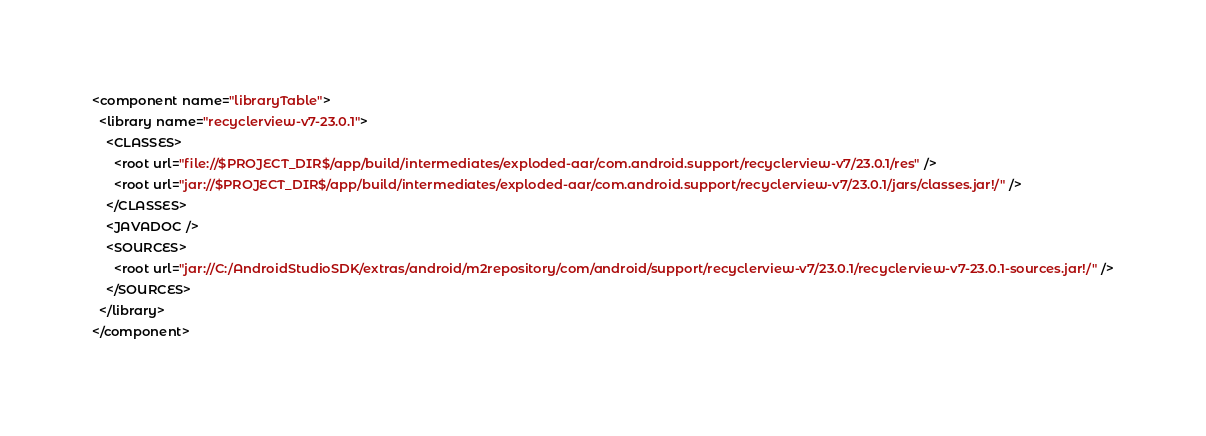<code> <loc_0><loc_0><loc_500><loc_500><_XML_><component name="libraryTable">
  <library name="recyclerview-v7-23.0.1">
    <CLASSES>
      <root url="file://$PROJECT_DIR$/app/build/intermediates/exploded-aar/com.android.support/recyclerview-v7/23.0.1/res" />
      <root url="jar://$PROJECT_DIR$/app/build/intermediates/exploded-aar/com.android.support/recyclerview-v7/23.0.1/jars/classes.jar!/" />
    </CLASSES>
    <JAVADOC />
    <SOURCES>
      <root url="jar://C:/AndroidStudioSDK/extras/android/m2repository/com/android/support/recyclerview-v7/23.0.1/recyclerview-v7-23.0.1-sources.jar!/" />
    </SOURCES>
  </library>
</component></code> 